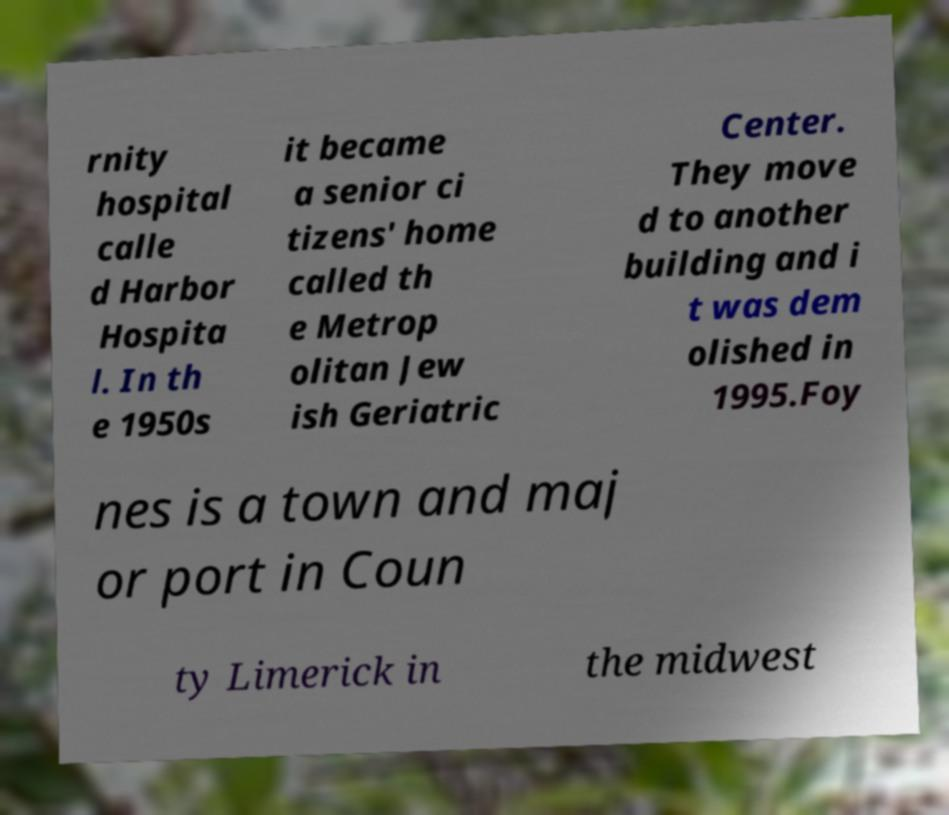There's text embedded in this image that I need extracted. Can you transcribe it verbatim? rnity hospital calle d Harbor Hospita l. In th e 1950s it became a senior ci tizens' home called th e Metrop olitan Jew ish Geriatric Center. They move d to another building and i t was dem olished in 1995.Foy nes is a town and maj or port in Coun ty Limerick in the midwest 